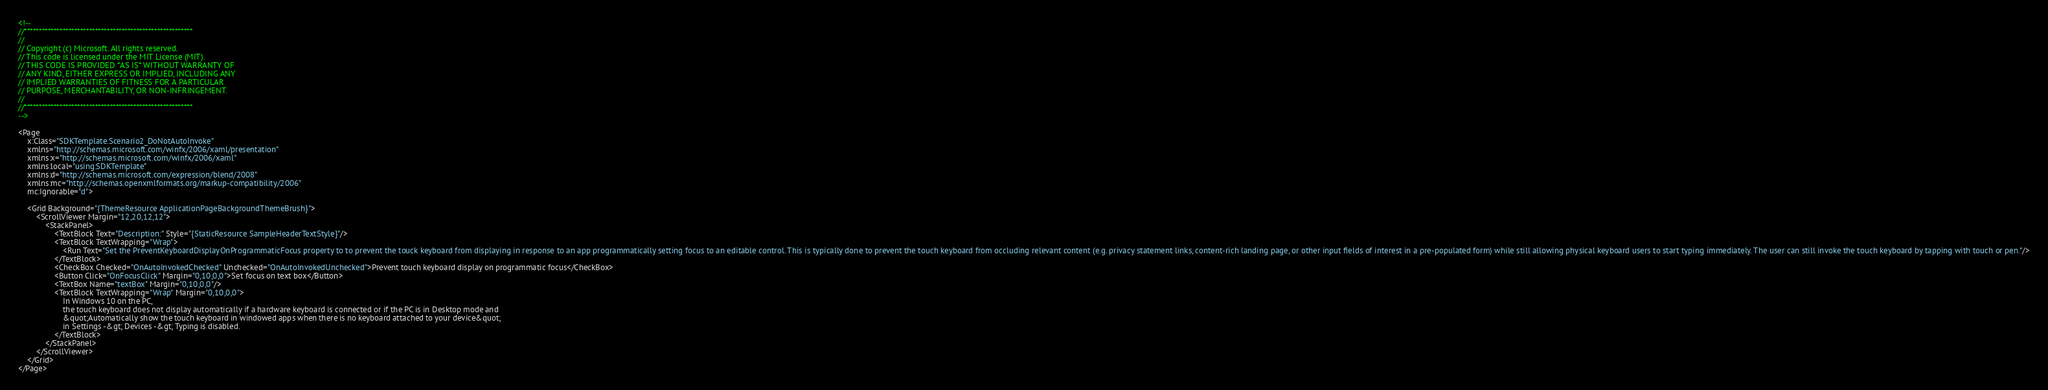Convert code to text. <code><loc_0><loc_0><loc_500><loc_500><_XML_><!-- 
//*********************************************************
//
// Copyright (c) Microsoft. All rights reserved.
// This code is licensed under the MIT License (MIT).
// THIS CODE IS PROVIDED *AS IS* WITHOUT WARRANTY OF
// ANY KIND, EITHER EXPRESS OR IMPLIED, INCLUDING ANY
// IMPLIED WARRANTIES OF FITNESS FOR A PARTICULAR
// PURPOSE, MERCHANTABILITY, OR NON-INFRINGEMENT.
//
//*********************************************************
-->

<Page
    x:Class="SDKTemplate.Scenario2_DoNotAutoInvoke"
    xmlns="http://schemas.microsoft.com/winfx/2006/xaml/presentation"
    xmlns:x="http://schemas.microsoft.com/winfx/2006/xaml"
    xmlns:local="using:SDKTemplate"
    xmlns:d="http://schemas.microsoft.com/expression/blend/2008"
    xmlns:mc="http://schemas.openxmlformats.org/markup-compatibility/2006"
    mc:Ignorable="d">

    <Grid Background="{ThemeResource ApplicationPageBackgroundThemeBrush}">
        <ScrollViewer Margin="12,20,12,12">
            <StackPanel>
                <TextBlock Text="Description:" Style="{StaticResource SampleHeaderTextStyle}"/>
                <TextBlock TextWrapping="Wrap">
                	<Run Text="Set the PreventKeyboardDisplayOnProgrammaticFocus property to to prevent the touck keyboard from displaying in response to an app programmatically setting focus to an editable control. This is typically done to prevent the touch keyboard from occluding relevant content (e.g. privacy statement links, content-rich landing page, or other input fields of interest in a pre-populated form) while still allowing physical keyboard users to start typing immediately. The user can still invoke the touch keyboard by tapping with touch or pen."/>
                </TextBlock>
                <CheckBox Checked="OnAutoInvokedChecked" Unchecked="OnAutoInvokedUnchecked">Prevent touch keyboard display on programmatic focus</CheckBox>
                <Button Click="OnFocusClick" Margin="0,10,0,0">Set focus on text box</Button>
                <TextBox Name="textBox" Margin="0,10,0,0"/>
                <TextBlock TextWrapping="Wrap" Margin="0,10,0,0">
                    In Windows 10 on the PC,
                    the touch keyboard does not display automatically if a hardware keyboard is connected or if the PC is in Desktop mode and
                    &quot;Automatically show the touch keyboard in windowed apps when there is no keyboard attached to your device&quot;
                    in Settings -&gt; Devices -&gt; Typing is disabled.
                </TextBlock>
            </StackPanel>
        </ScrollViewer>
    </Grid>
</Page>
</code> 